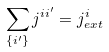<formula> <loc_0><loc_0><loc_500><loc_500>\sum _ { \{ i ^ { \prime } \} } j ^ { i i ^ { \prime } } = j _ { e x t } ^ { i }</formula> 